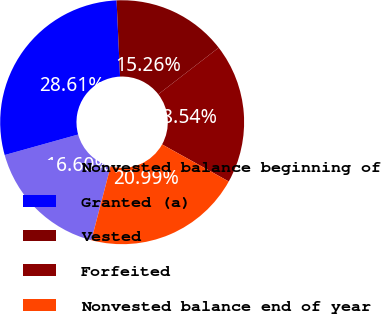Convert chart to OTSL. <chart><loc_0><loc_0><loc_500><loc_500><pie_chart><fcel>Nonvested balance beginning of<fcel>Granted (a)<fcel>Vested<fcel>Forfeited<fcel>Nonvested balance end of year<nl><fcel>16.6%<fcel>28.61%<fcel>15.26%<fcel>18.54%<fcel>20.99%<nl></chart> 